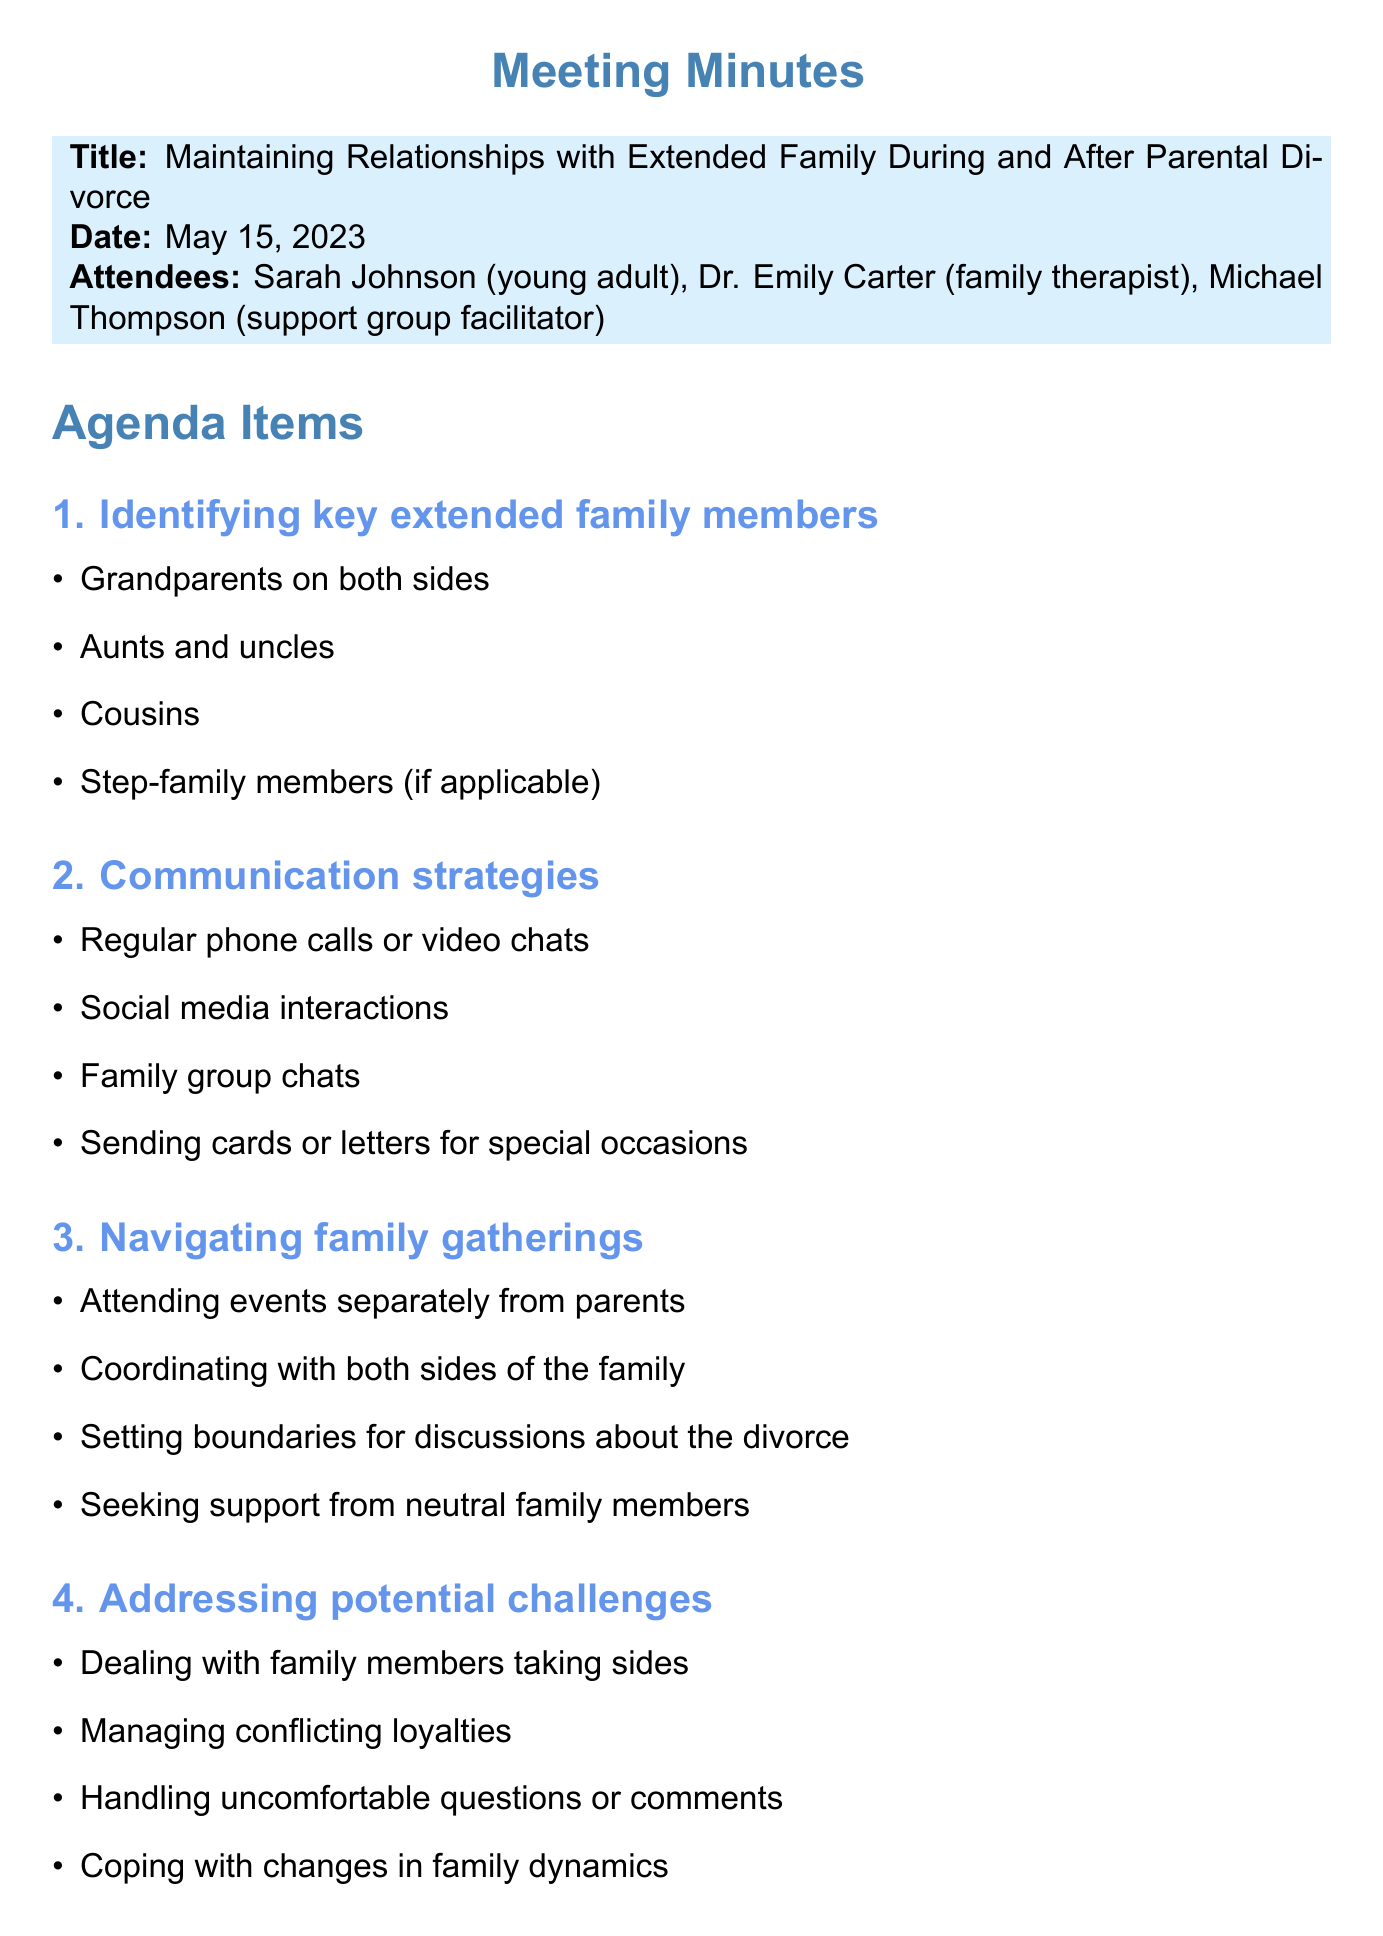What is the meeting title? The meeting title is found at the beginning of the document, which specifies the focus of the discussion.
Answer: Maintaining Relationships with Extended Family During and After Parental Divorce Who are the attendees? The attendees are listed under the attendees section and provide the names and roles of participants.
Answer: Sarah Johnson, Dr. Emily Carter, Michael Thompson What is the date of the meeting? The meeting date is indicated in bold format right after the title of the document.
Answer: May 15, 2023 What is one topic discussed related to communication strategies? The document outlines multiple discussion points under the communication strategies topic, highlighting various methods of interacting with extended family.
Answer: Regular phone calls or video chats What are two key extended family members mentioned? The first agenda item lists the key extended family members that were identified for maintaining relationships.
Answer: Grandparents on both sides, Aunts and uncles What is one challenge addressed during the meeting? The fourth agenda item outlines various potential challenges faced by young adults during their parents' divorce with respect to family dynamics.
Answer: Dealing with family members taking sides What is one new tradition suggested in the meeting? The fifth agenda item offers ideas for creating new family traditions to foster connections among extended family members.
Answer: Organizing cousin get-togethers What is one action item assigned to Sarah? The action items section specifies tasks given to participants and their respective responsibilities regarding follow-up actions.
Answer: Create a contact list of key extended family members When is the next meeting scheduled? The schedule for the next meeting is documented at the end of the meeting minutes, indicating the follow-up date for discussion.
Answer: June 12, 2023 